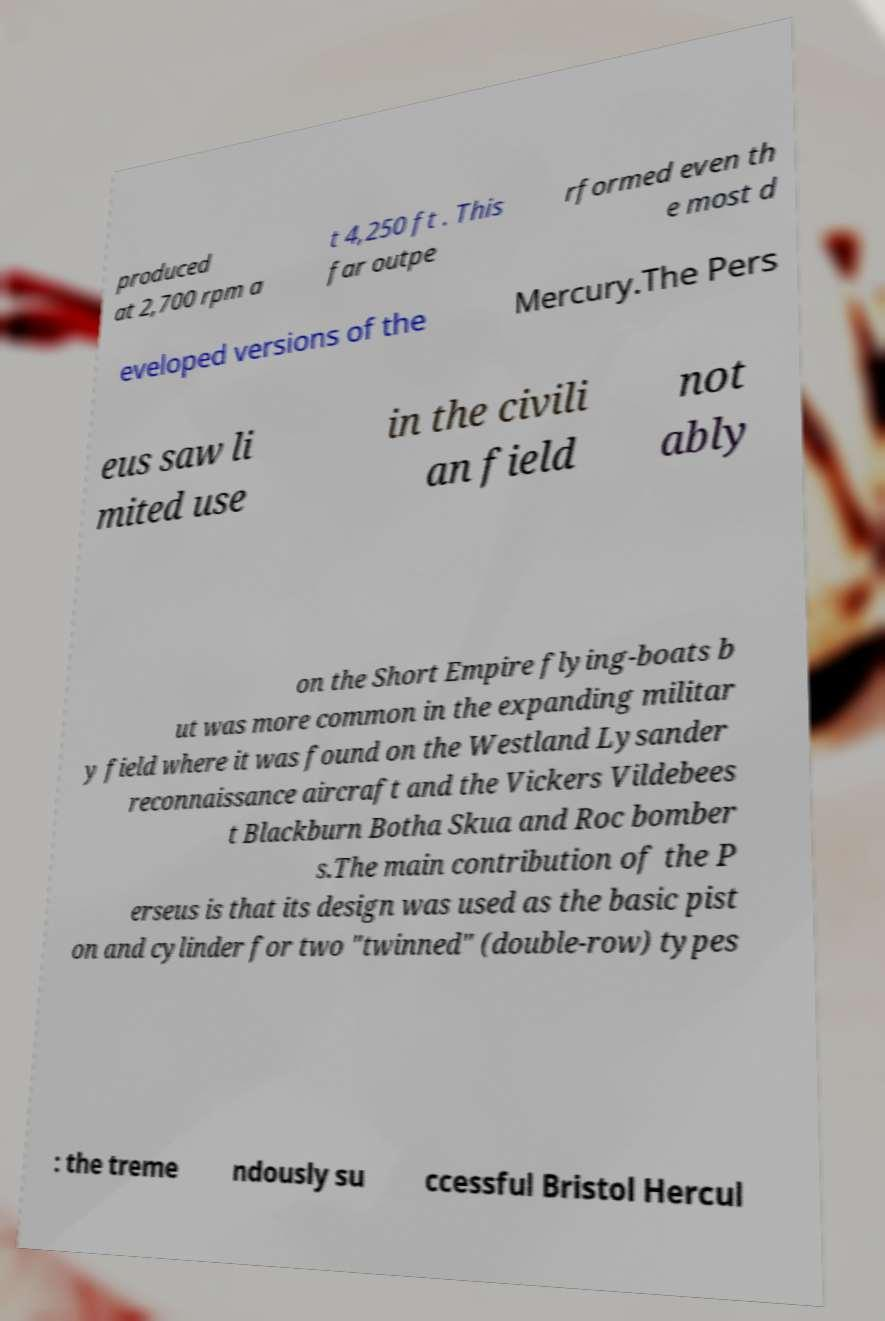Please identify and transcribe the text found in this image. produced at 2,700 rpm a t 4,250 ft . This far outpe rformed even th e most d eveloped versions of the Mercury.The Pers eus saw li mited use in the civili an field not ably on the Short Empire flying-boats b ut was more common in the expanding militar y field where it was found on the Westland Lysander reconnaissance aircraft and the Vickers Vildebees t Blackburn Botha Skua and Roc bomber s.The main contribution of the P erseus is that its design was used as the basic pist on and cylinder for two "twinned" (double-row) types : the treme ndously su ccessful Bristol Hercul 